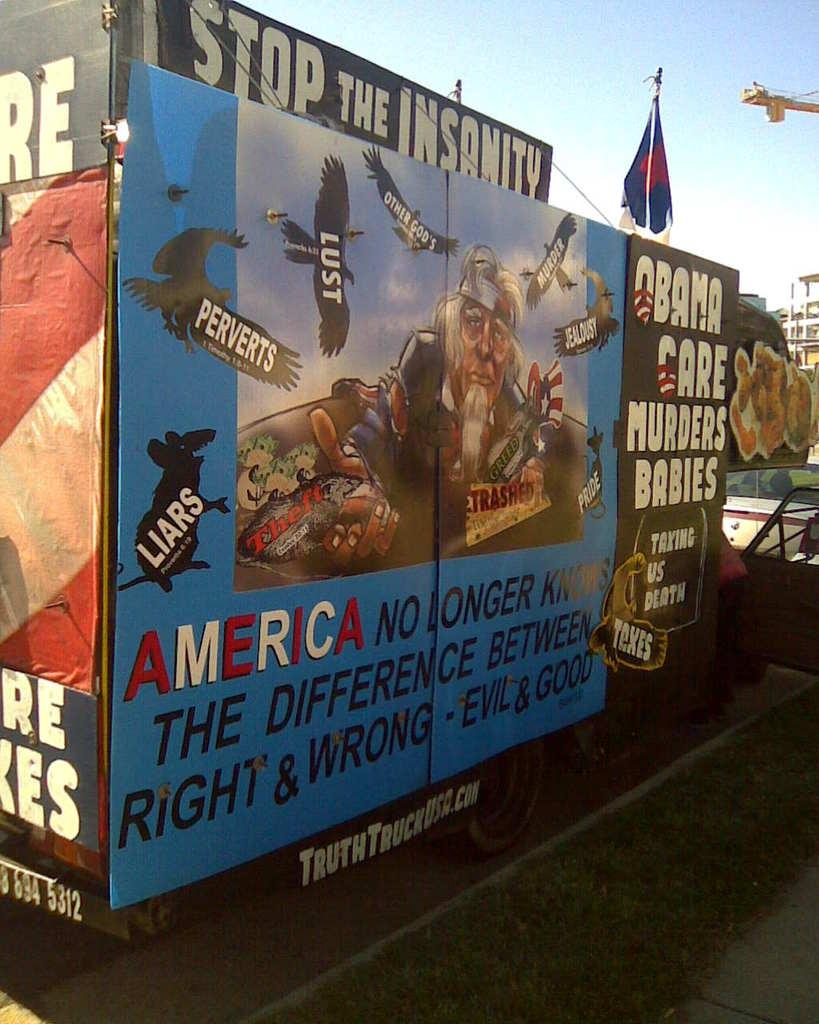<image>
Give a short and clear explanation of the subsequent image. Large sign that says Stop The Insanity at the top. 